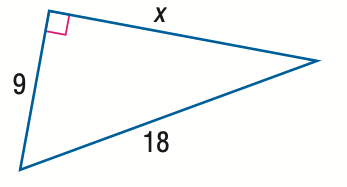Answer the mathemtical geometry problem and directly provide the correct option letter.
Question: Find x.
Choices: A: 3 \sqrt { 3 } B: 9 C: 9 \sqrt { 2 } D: 9 \sqrt { 3 } D 